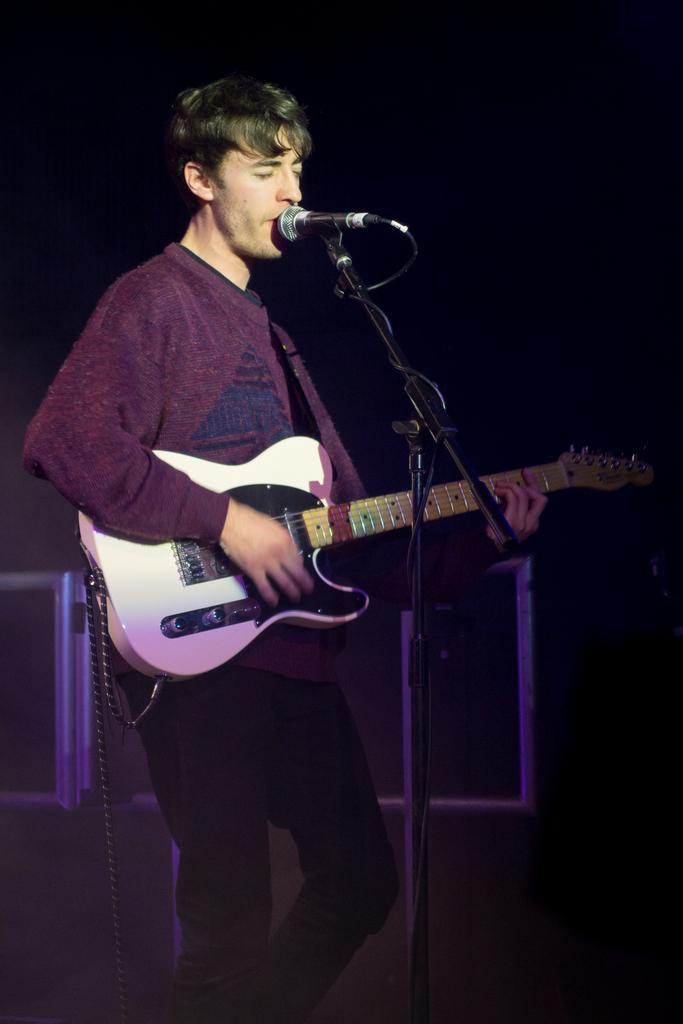In one or two sentences, can you explain what this image depicts? In this image I can see a man is standing and holding a guitar. i can also see a mic in front of him. 